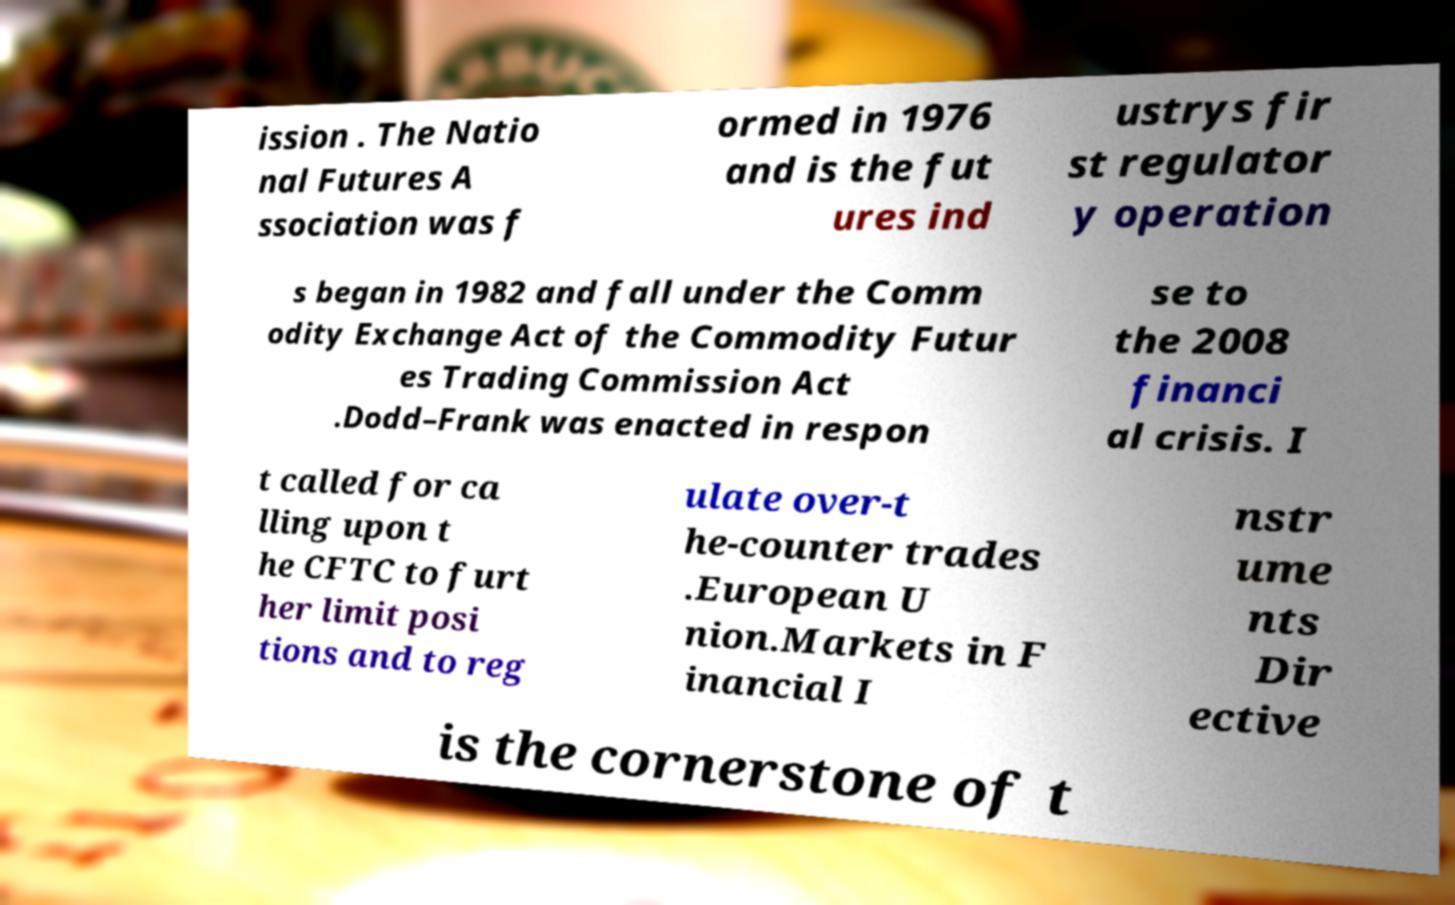Could you assist in decoding the text presented in this image and type it out clearly? ission . The Natio nal Futures A ssociation was f ormed in 1976 and is the fut ures ind ustrys fir st regulator y operation s began in 1982 and fall under the Comm odity Exchange Act of the Commodity Futur es Trading Commission Act .Dodd–Frank was enacted in respon se to the 2008 financi al crisis. I t called for ca lling upon t he CFTC to furt her limit posi tions and to reg ulate over-t he-counter trades .European U nion.Markets in F inancial I nstr ume nts Dir ective is the cornerstone of t 